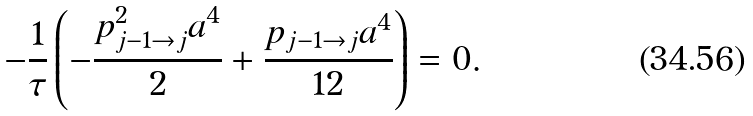<formula> <loc_0><loc_0><loc_500><loc_500>- \frac { 1 } { \tau } \left ( - \frac { p _ { j - 1 \to j } ^ { 2 } a ^ { 4 } } { 2 } + \frac { p _ { j - 1 \to j } a ^ { 4 } } { 1 2 } \right ) = 0 .</formula> 